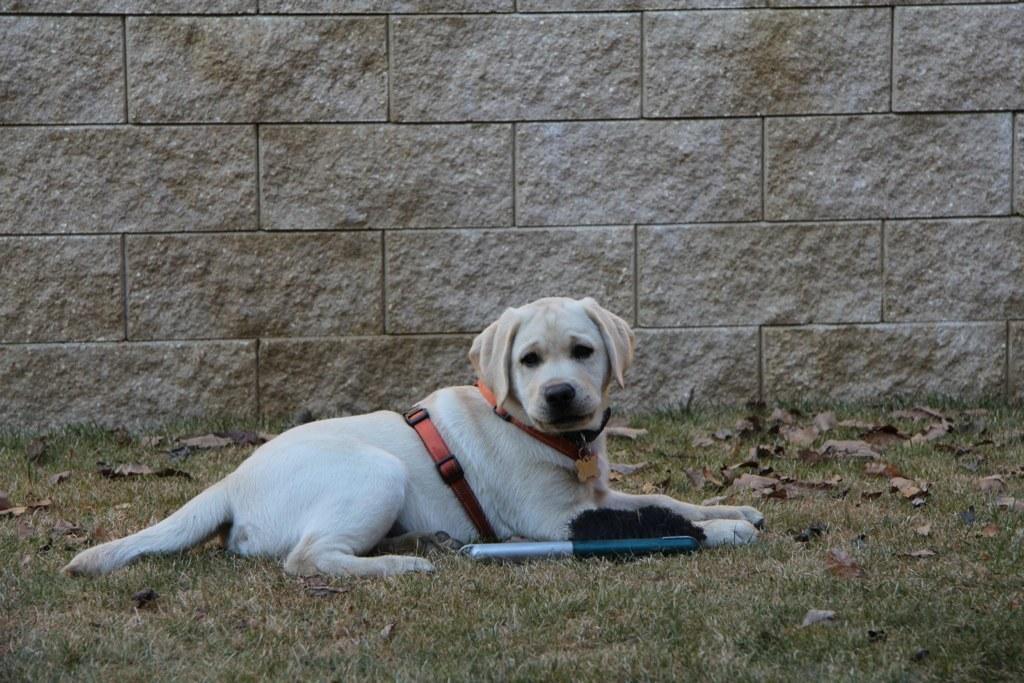Please provide a concise description of this image. In the center of the image there is a dog. At the bottom of the image there is grass. In the background of the image there is wall. 